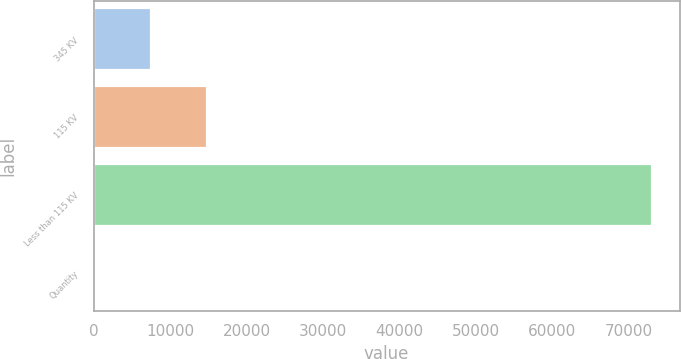Convert chart to OTSL. <chart><loc_0><loc_0><loc_500><loc_500><bar_chart><fcel>345 KV<fcel>115 KV<fcel>Less than 115 KV<fcel>Quantity<nl><fcel>7496.9<fcel>14772.8<fcel>72980<fcel>221<nl></chart> 